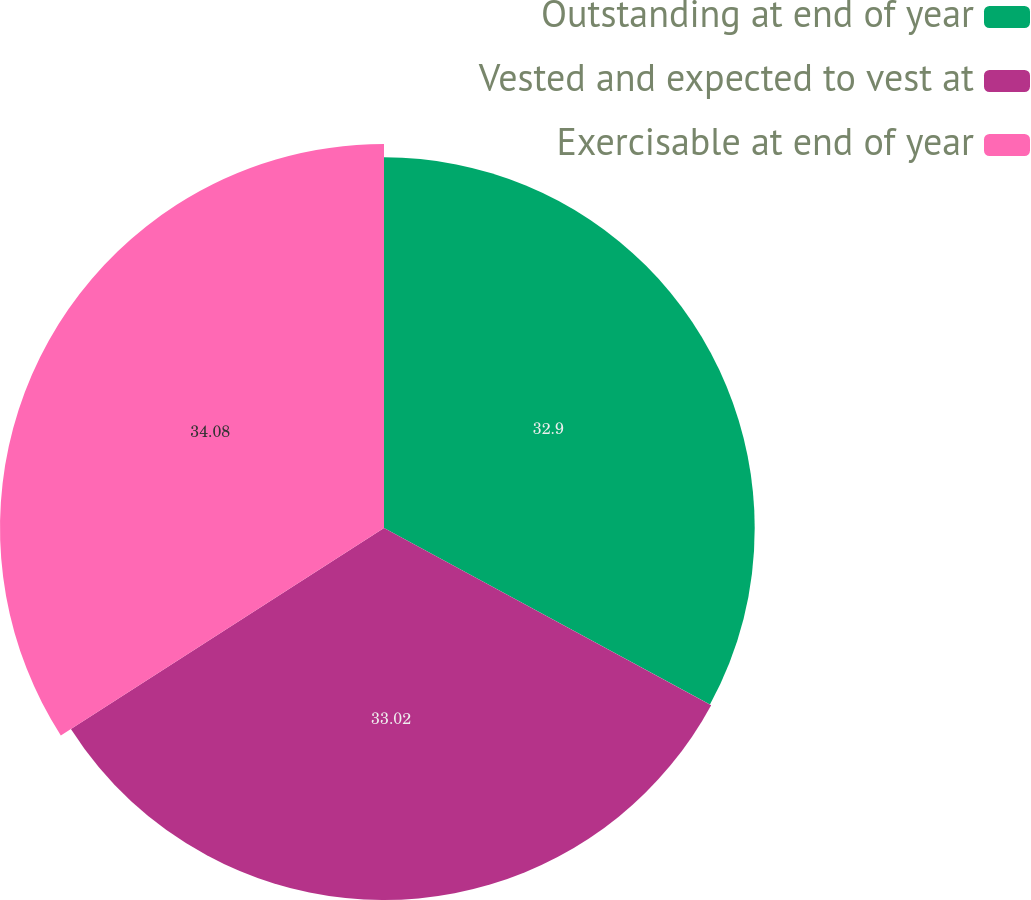<chart> <loc_0><loc_0><loc_500><loc_500><pie_chart><fcel>Outstanding at end of year<fcel>Vested and expected to vest at<fcel>Exercisable at end of year<nl><fcel>32.9%<fcel>33.02%<fcel>34.08%<nl></chart> 